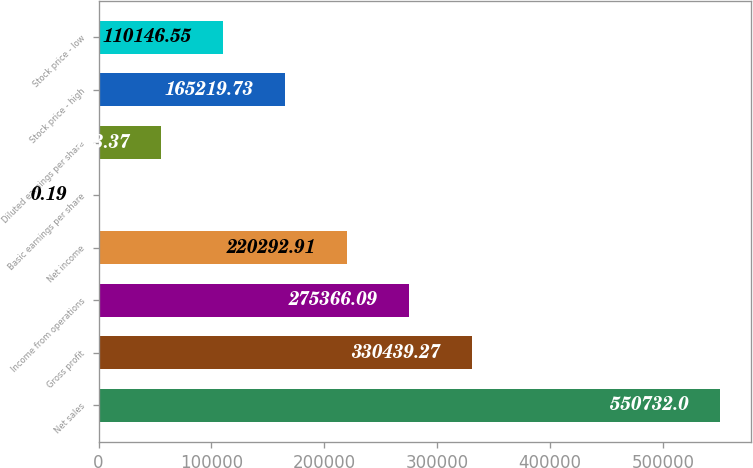<chart> <loc_0><loc_0><loc_500><loc_500><bar_chart><fcel>Net sales<fcel>Gross profit<fcel>Income from operations<fcel>Net income<fcel>Basic earnings per share<fcel>Diluted earnings per share<fcel>Stock price - high<fcel>Stock price - low<nl><fcel>550732<fcel>330439<fcel>275366<fcel>220293<fcel>0.19<fcel>55073.4<fcel>165220<fcel>110147<nl></chart> 